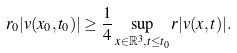Convert formula to latex. <formula><loc_0><loc_0><loc_500><loc_500>r _ { 0 } | v ( x _ { 0 } , t _ { 0 } ) | \geq \frac { 1 } { 4 } \sup _ { x \in \mathbb { R } ^ { 3 } , t \leq t _ { 0 } } r | v ( x , t ) | .</formula> 